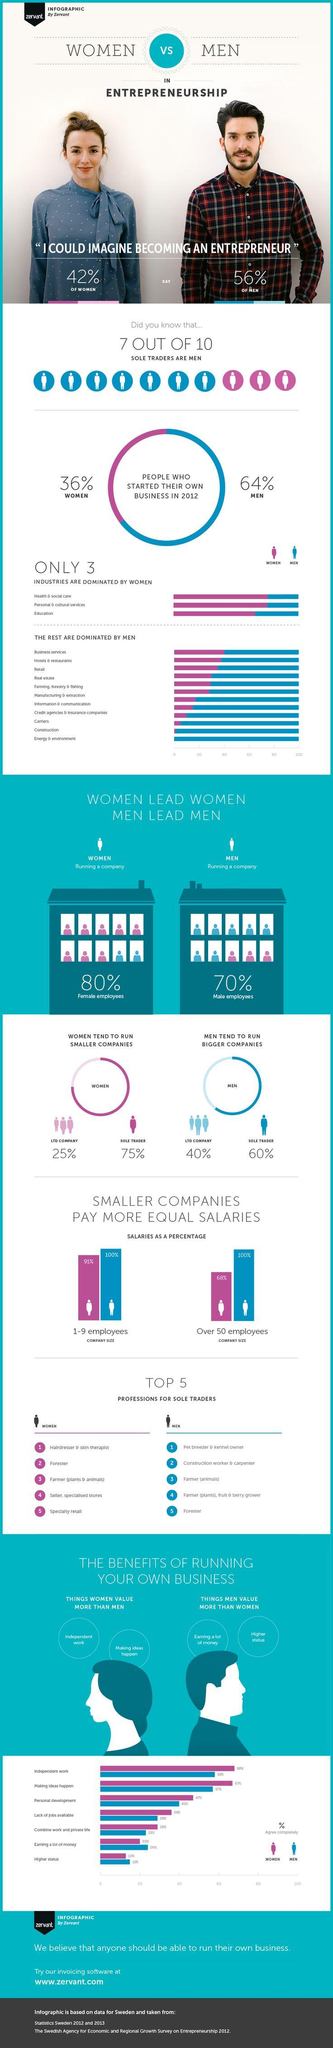Mention a couple of crucial points in this snapshot. Out of the total number of industries, 11 are dominated by men. Out of all industries, only 11 are not dominated by women. In 2012, approximately 56% of men started their own business. Out of 10, only 3 sole traders are not men. The industries of health and social care, personal and cultural services, and education are some of the few that are not dominated by men. 